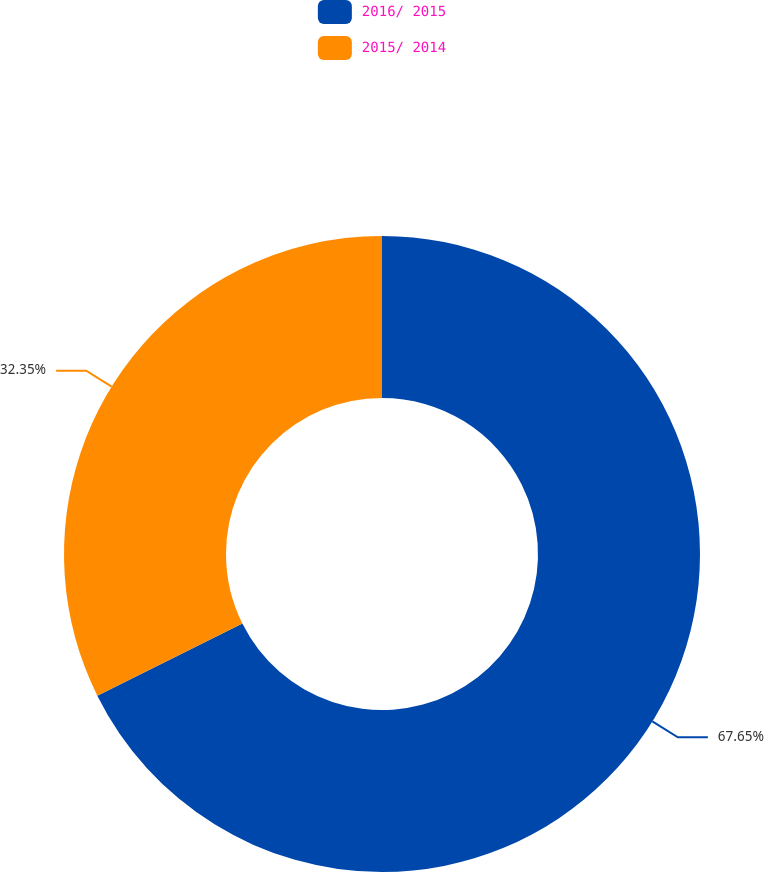Convert chart. <chart><loc_0><loc_0><loc_500><loc_500><pie_chart><fcel>2016/ 2015<fcel>2015/ 2014<nl><fcel>67.65%<fcel>32.35%<nl></chart> 